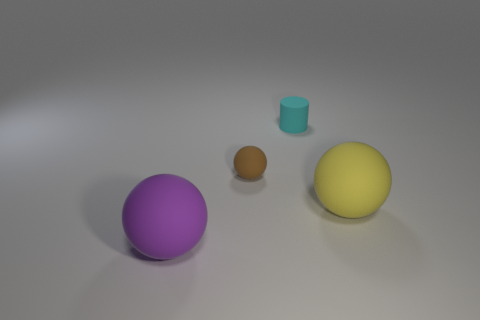There is a cyan thing that is made of the same material as the large purple object; what is its size?
Your answer should be very brief. Small. What number of cylinders are either brown things or yellow things?
Your answer should be very brief. 0. What color is the big rubber sphere that is on the right side of the big rubber ball that is in front of the yellow rubber sphere?
Provide a short and direct response. Yellow. There is a brown sphere that is right of the big rubber sphere to the left of the cyan rubber cylinder; what number of purple spheres are in front of it?
Offer a terse response. 1. There is a object that is right of the cyan rubber cylinder; is it the same shape as the big matte object to the left of the brown sphere?
Your response must be concise. Yes. How many things are either tiny red shiny balls or yellow matte spheres?
Ensure brevity in your answer.  1. What is the color of the thing that is the same size as the cyan rubber cylinder?
Keep it short and to the point. Brown. What is the material of the ball in front of the big thing that is behind the large object that is left of the yellow object?
Keep it short and to the point. Rubber. What number of things are either things on the left side of the yellow object or large matte spheres on the right side of the purple matte ball?
Keep it short and to the point. 4. What is the shape of the large rubber object to the left of the large matte sphere on the right side of the small cyan object?
Provide a short and direct response. Sphere. 